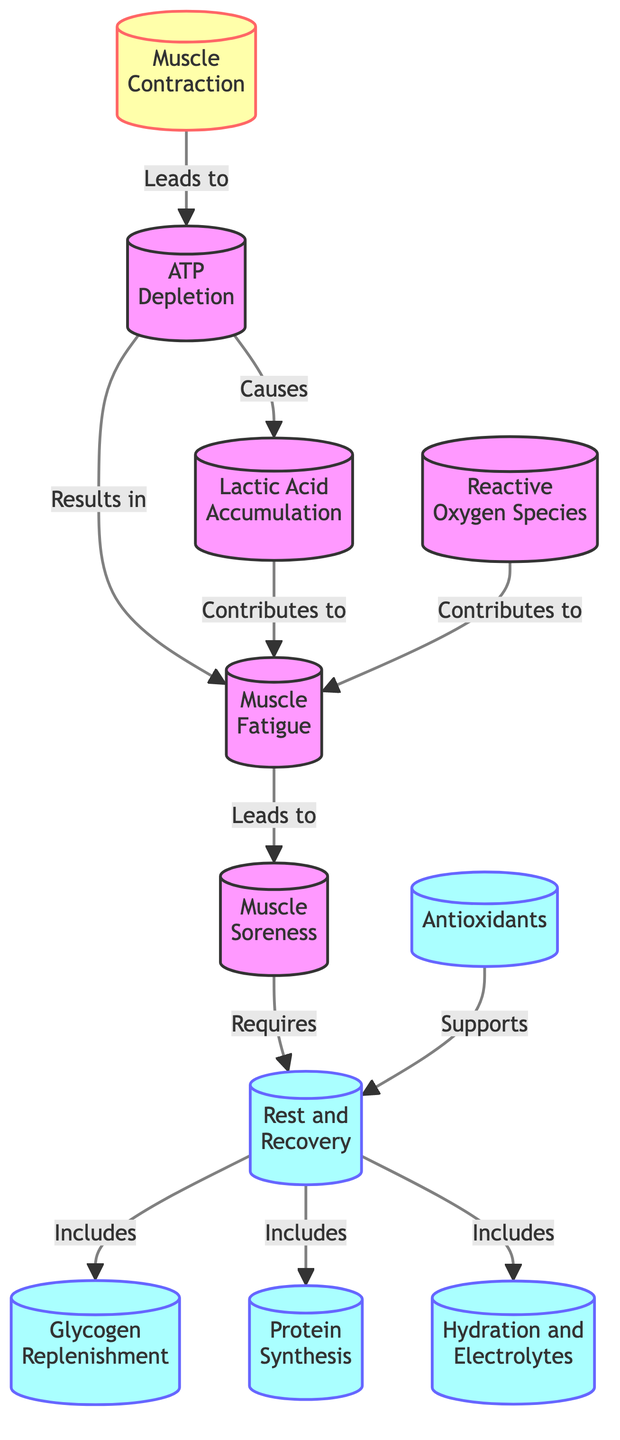What leads to ATP Depletion? The diagram indicates that Muscle Contraction leads to ATP Depletion. Muscle Contraction is the starting point that directly causes the depletion of ATP.
Answer: Muscle Contraction What is a consequence of Lactic Acid Accumulation? The diagram shows that Lactic Acid Accumulation contributes to Muscle Fatigue. Hence, the consequence of lactic acid accumulation is muscle fatigue.
Answer: Muscle Fatigue How many recovery processes are listed in the diagram? Upon reviewing the recovery section of the diagram, there are five processes listed: Rest and Recovery, Glycogen Replenishment, Protein Synthesis, Hydration and Electrolytes, Antioxidants. Therefore, there are five recovery processes.
Answer: 5 What supports Rest and Recovery? The diagram states that Antioxidants support Rest and Recovery. Therefore, the supporting element for recovery is antioxidants.
Answer: Antioxidants What condition requires Rest and Recovery? According to the diagram, Muscle Soreness requires Rest and Recovery. Muscle soreness is directly connected to the need for recovery processes.
Answer: Muscle Soreness How does Muscle Fatigue relate to other elements in the diagram? The diagram indicates that Muscle Fatigue is a result of ATP Depletion, Lactic Acid Accumulation, and Reactive Oxygen Species, showing that it has multiple causes that contribute to it.
Answer: ATP Depletion, Lactic Acid Accumulation, Reactive Oxygen Species Which process leads to Muscle Soreness? The diagram indicates that Muscle Fatigue leads to Muscle Soreness, identifying fatigue as a primary cause of soreness in muscles.
Answer: Muscle Fatigue How many nodes are there depicting recovery processes in relation to Rest and Recovery? There are four nodes connected to Rest and Recovery, which are Glycogen Replenishment, Protein Synthesis, Hydration and Electrolytes, and Antioxidants, indicating the processes associated with recovery.
Answer: 4 What is the first event in the series of events leading to Muscle Fatigue? The first event causing a series of events leading to Muscle Fatigue is ATP Depletion, as it is the primary cause that initiates the fatigue process.
Answer: ATP Depletion 